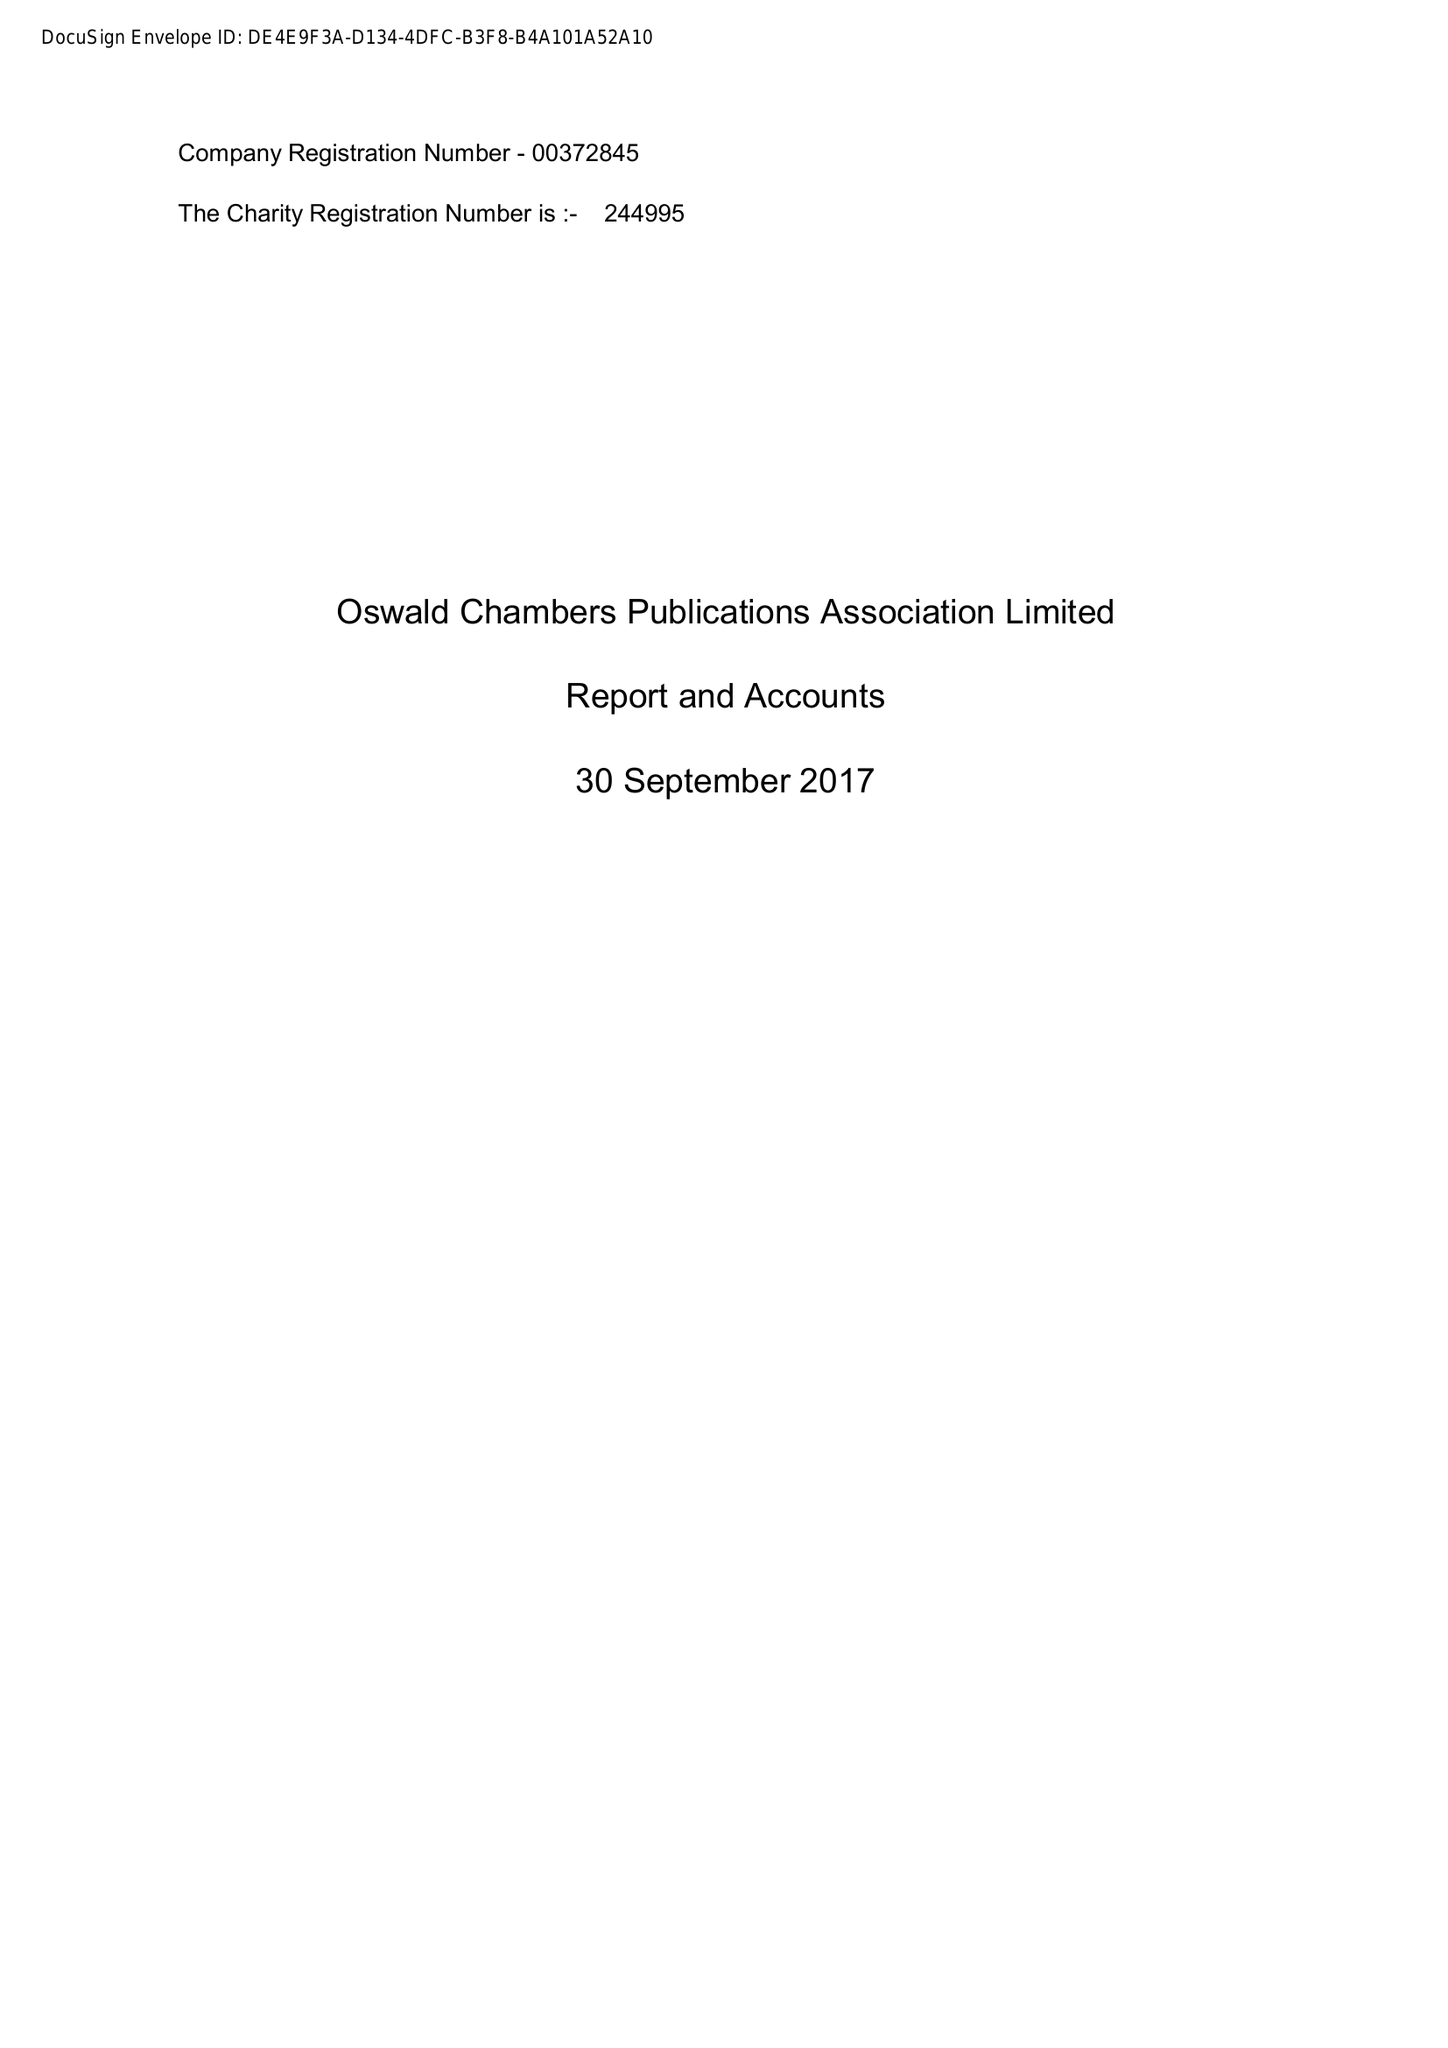What is the value for the report_date?
Answer the question using a single word or phrase. 2017-09-30 